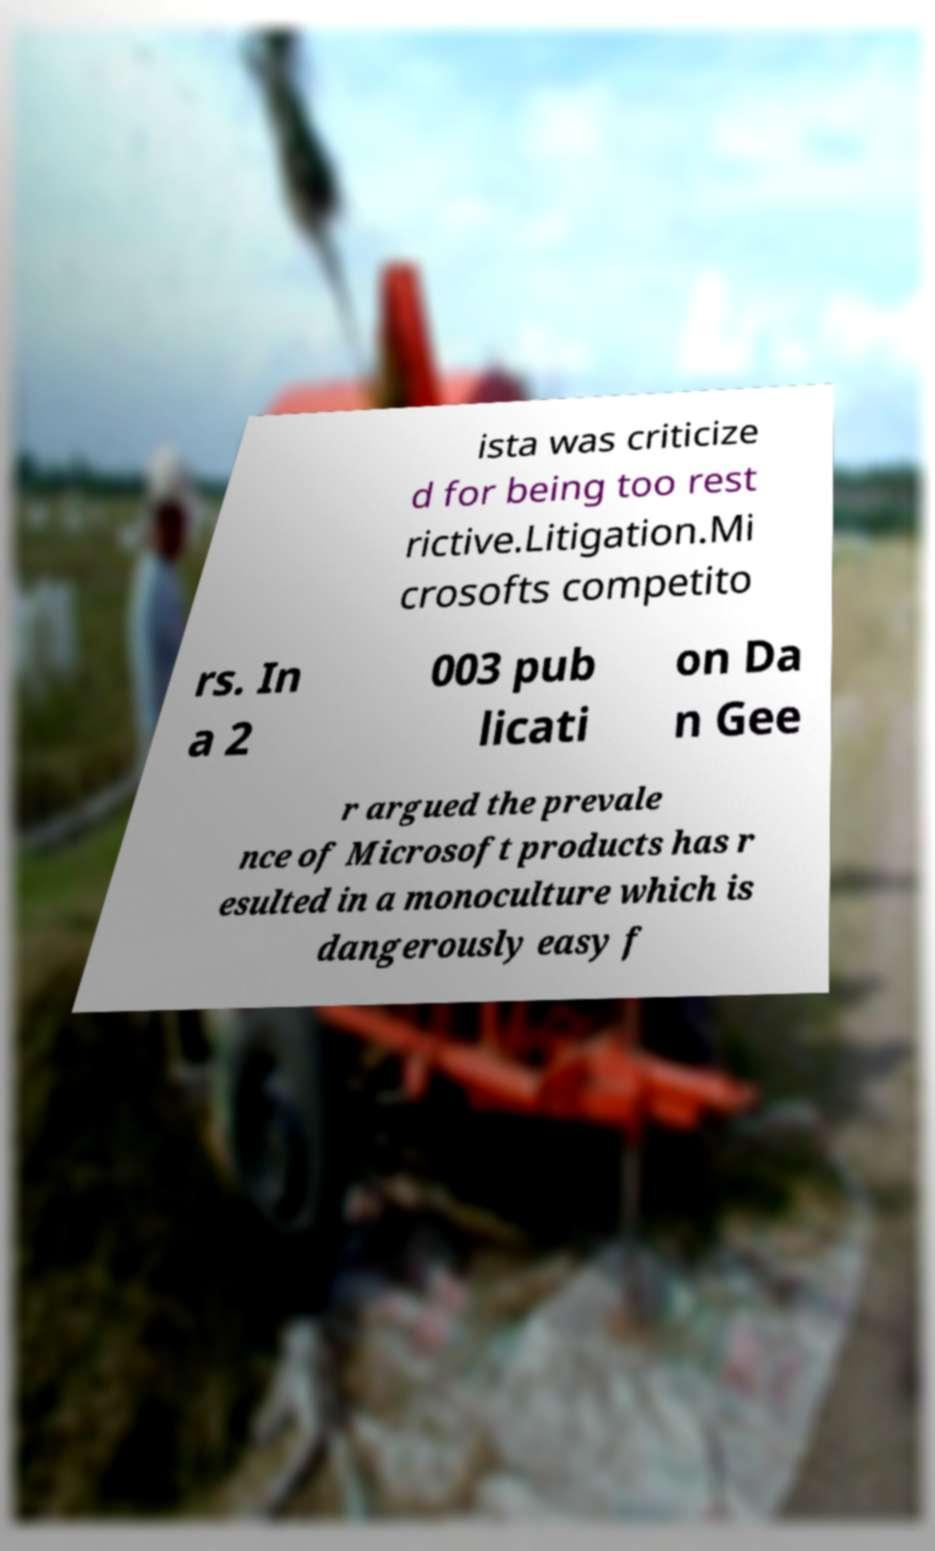For documentation purposes, I need the text within this image transcribed. Could you provide that? ista was criticize d for being too rest rictive.Litigation.Mi crosofts competito rs. In a 2 003 pub licati on Da n Gee r argued the prevale nce of Microsoft products has r esulted in a monoculture which is dangerously easy f 